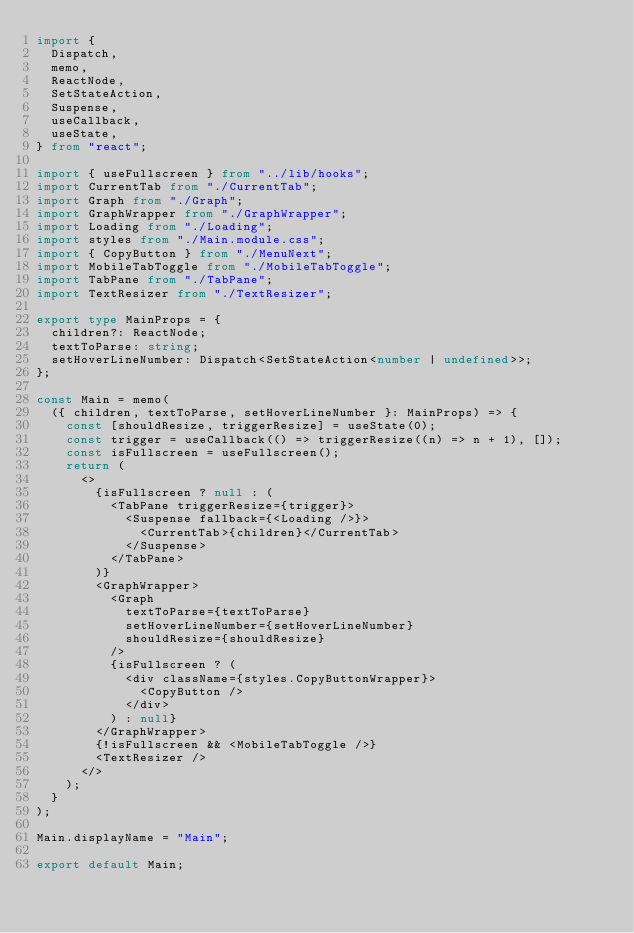<code> <loc_0><loc_0><loc_500><loc_500><_TypeScript_>import {
  Dispatch,
  memo,
  ReactNode,
  SetStateAction,
  Suspense,
  useCallback,
  useState,
} from "react";

import { useFullscreen } from "../lib/hooks";
import CurrentTab from "./CurrentTab";
import Graph from "./Graph";
import GraphWrapper from "./GraphWrapper";
import Loading from "./Loading";
import styles from "./Main.module.css";
import { CopyButton } from "./MenuNext";
import MobileTabToggle from "./MobileTabToggle";
import TabPane from "./TabPane";
import TextResizer from "./TextResizer";

export type MainProps = {
  children?: ReactNode;
  textToParse: string;
  setHoverLineNumber: Dispatch<SetStateAction<number | undefined>>;
};

const Main = memo(
  ({ children, textToParse, setHoverLineNumber }: MainProps) => {
    const [shouldResize, triggerResize] = useState(0);
    const trigger = useCallback(() => triggerResize((n) => n + 1), []);
    const isFullscreen = useFullscreen();
    return (
      <>
        {isFullscreen ? null : (
          <TabPane triggerResize={trigger}>
            <Suspense fallback={<Loading />}>
              <CurrentTab>{children}</CurrentTab>
            </Suspense>
          </TabPane>
        )}
        <GraphWrapper>
          <Graph
            textToParse={textToParse}
            setHoverLineNumber={setHoverLineNumber}
            shouldResize={shouldResize}
          />
          {isFullscreen ? (
            <div className={styles.CopyButtonWrapper}>
              <CopyButton />
            </div>
          ) : null}
        </GraphWrapper>
        {!isFullscreen && <MobileTabToggle />}
        <TextResizer />
      </>
    );
  }
);

Main.displayName = "Main";

export default Main;
</code> 